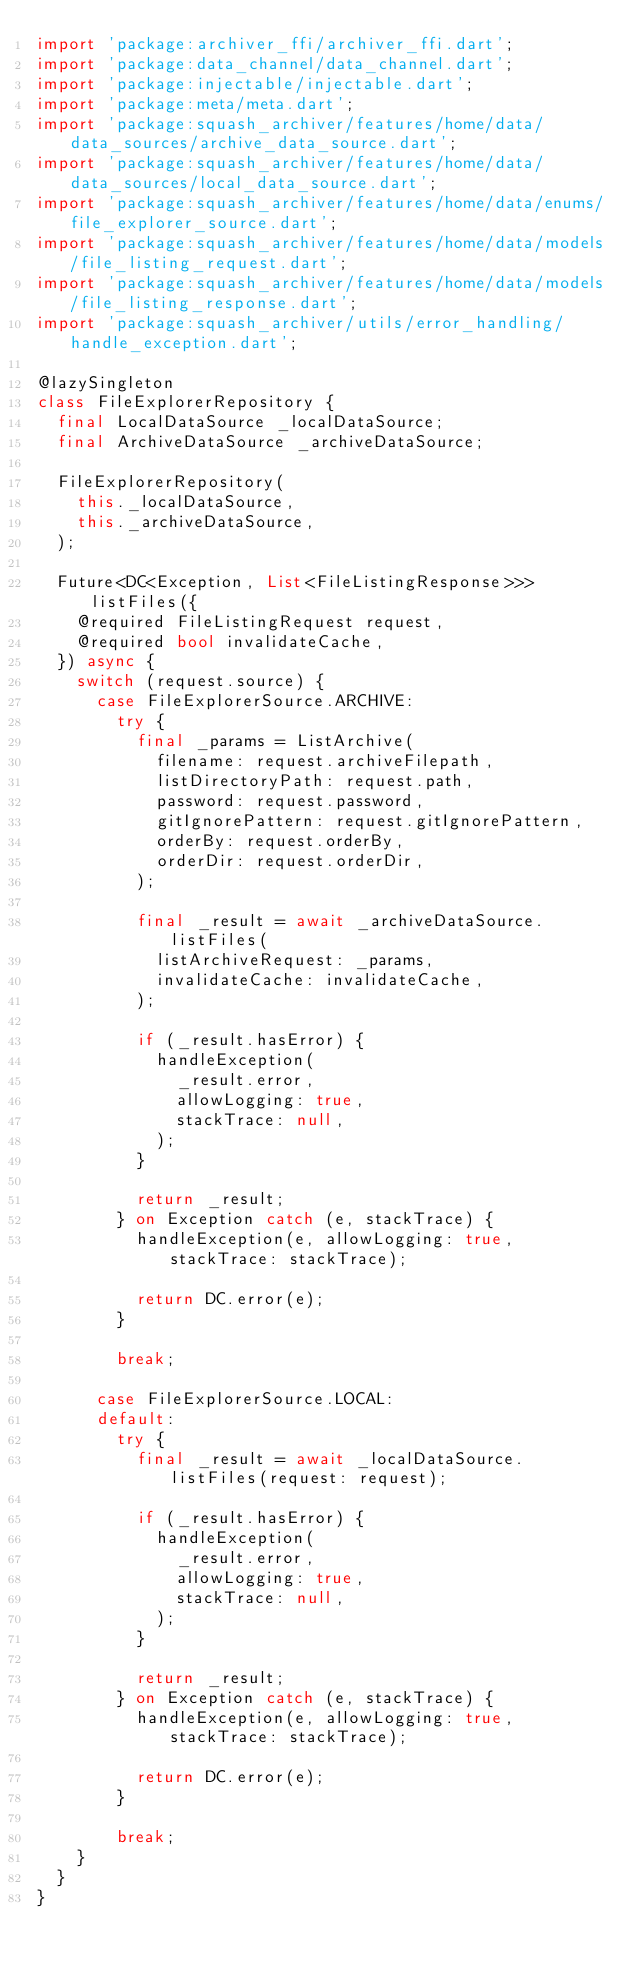Convert code to text. <code><loc_0><loc_0><loc_500><loc_500><_Dart_>import 'package:archiver_ffi/archiver_ffi.dart';
import 'package:data_channel/data_channel.dart';
import 'package:injectable/injectable.dart';
import 'package:meta/meta.dart';
import 'package:squash_archiver/features/home/data/data_sources/archive_data_source.dart';
import 'package:squash_archiver/features/home/data/data_sources/local_data_source.dart';
import 'package:squash_archiver/features/home/data/enums/file_explorer_source.dart';
import 'package:squash_archiver/features/home/data/models/file_listing_request.dart';
import 'package:squash_archiver/features/home/data/models/file_listing_response.dart';
import 'package:squash_archiver/utils/error_handling/handle_exception.dart';

@lazySingleton
class FileExplorerRepository {
  final LocalDataSource _localDataSource;
  final ArchiveDataSource _archiveDataSource;

  FileExplorerRepository(
    this._localDataSource,
    this._archiveDataSource,
  );

  Future<DC<Exception, List<FileListingResponse>>> listFiles({
    @required FileListingRequest request,
    @required bool invalidateCache,
  }) async {
    switch (request.source) {
      case FileExplorerSource.ARCHIVE:
        try {
          final _params = ListArchive(
            filename: request.archiveFilepath,
            listDirectoryPath: request.path,
            password: request.password,
            gitIgnorePattern: request.gitIgnorePattern,
            orderBy: request.orderBy,
            orderDir: request.orderDir,
          );

          final _result = await _archiveDataSource.listFiles(
            listArchiveRequest: _params,
            invalidateCache: invalidateCache,
          );

          if (_result.hasError) {
            handleException(
              _result.error,
              allowLogging: true,
              stackTrace: null,
            );
          }

          return _result;
        } on Exception catch (e, stackTrace) {
          handleException(e, allowLogging: true, stackTrace: stackTrace);

          return DC.error(e);
        }

        break;

      case FileExplorerSource.LOCAL:
      default:
        try {
          final _result = await _localDataSource.listFiles(request: request);

          if (_result.hasError) {
            handleException(
              _result.error,
              allowLogging: true,
              stackTrace: null,
            );
          }

          return _result;
        } on Exception catch (e, stackTrace) {
          handleException(e, allowLogging: true, stackTrace: stackTrace);

          return DC.error(e);
        }

        break;
    }
  }
}
</code> 